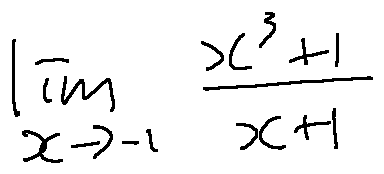<formula> <loc_0><loc_0><loc_500><loc_500>\lim \lim i t s _ { x \rightarrow - 1 } \frac { x ^ { 3 } + 1 } { x + 1 }</formula> 